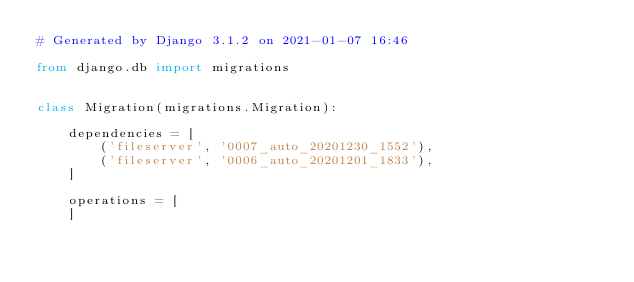Convert code to text. <code><loc_0><loc_0><loc_500><loc_500><_Python_># Generated by Django 3.1.2 on 2021-01-07 16:46

from django.db import migrations


class Migration(migrations.Migration):

    dependencies = [
        ('fileserver', '0007_auto_20201230_1552'),
        ('fileserver', '0006_auto_20201201_1833'),
    ]

    operations = [
    ]
</code> 